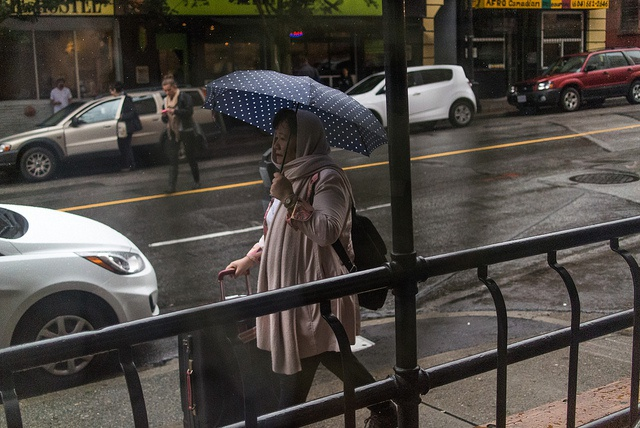Describe the objects in this image and their specific colors. I can see people in black, gray, and darkgray tones, car in black, white, gray, and darkgray tones, car in black, gray, darkgray, and lightgray tones, umbrella in black and gray tones, and suitcase in black and gray tones in this image. 